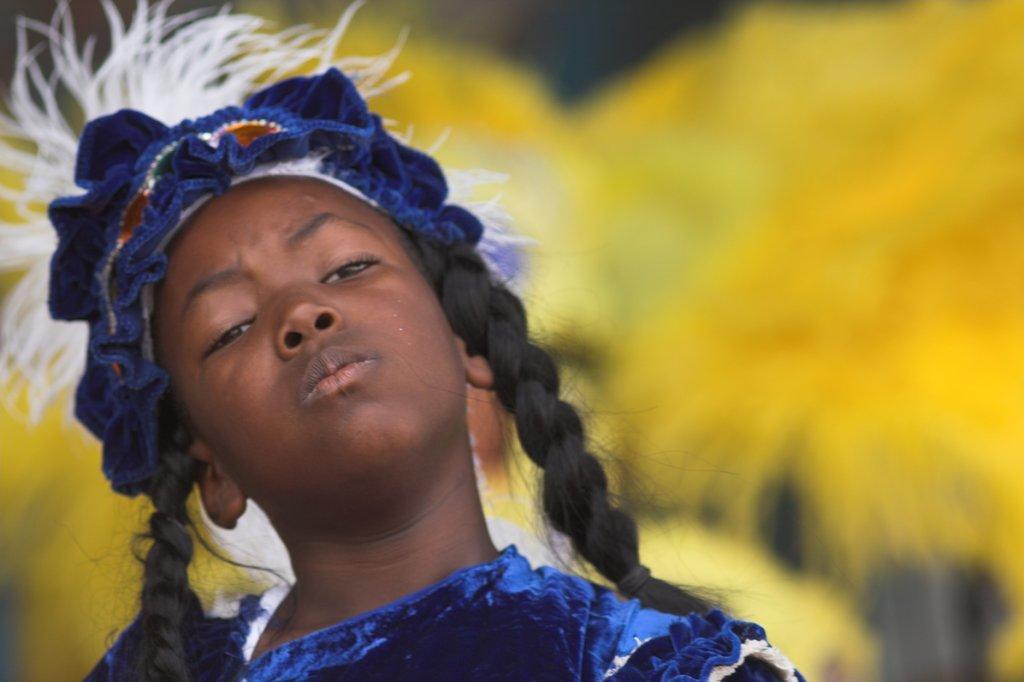Describe this image in one or two sentences. In this image we can see a girl wearing a costume. The background is blurry. 